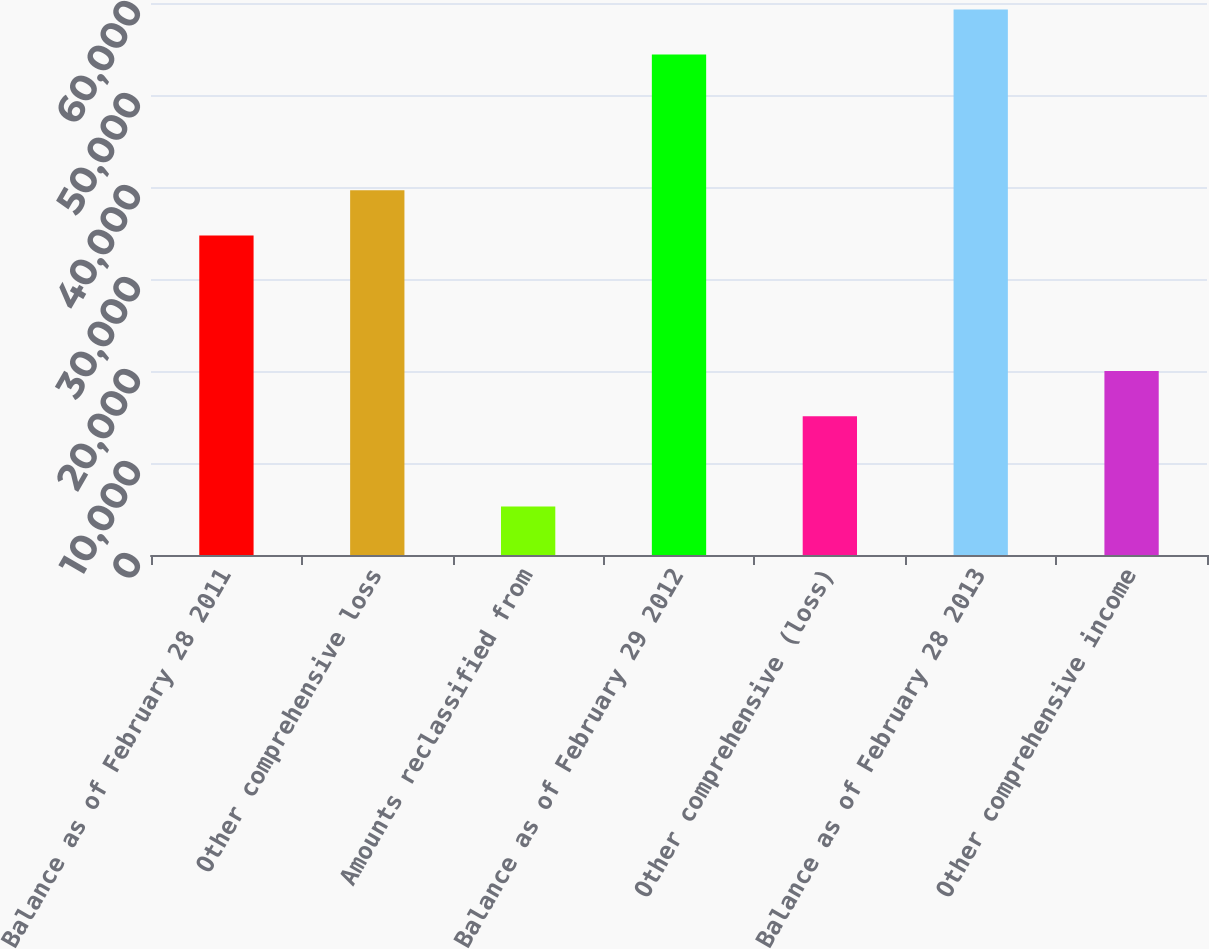Convert chart. <chart><loc_0><loc_0><loc_500><loc_500><bar_chart><fcel>Balance as of February 28 2011<fcel>Other comprehensive loss<fcel>Amounts reclassified from<fcel>Balance as of February 29 2012<fcel>Other comprehensive (loss)<fcel>Balance as of February 28 2013<fcel>Other comprehensive income<nl><fcel>34738.8<fcel>39652.2<fcel>5258.4<fcel>54392.4<fcel>15085.2<fcel>59305.8<fcel>19998.6<nl></chart> 